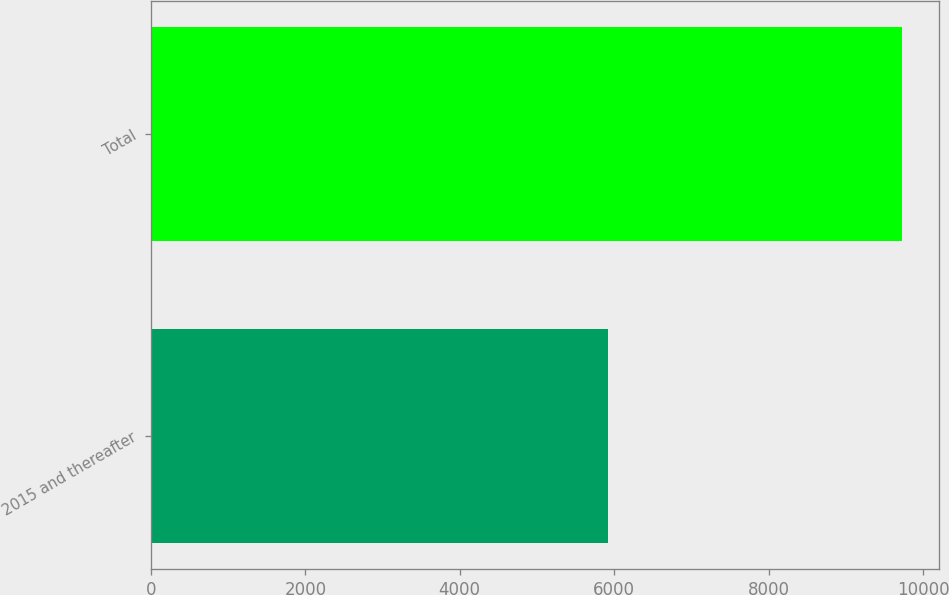Convert chart to OTSL. <chart><loc_0><loc_0><loc_500><loc_500><bar_chart><fcel>2015 and thereafter<fcel>Total<nl><fcel>5925<fcel>9725<nl></chart> 